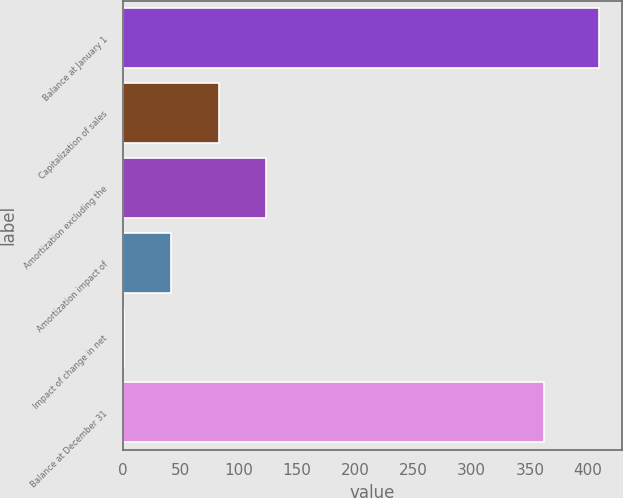Convert chart. <chart><loc_0><loc_0><loc_500><loc_500><bar_chart><fcel>Balance at January 1<fcel>Capitalization of sales<fcel>Amortization excluding the<fcel>Amortization impact of<fcel>Impact of change in net<fcel>Balance at December 31<nl><fcel>409<fcel>82.6<fcel>123.4<fcel>41.8<fcel>1<fcel>362<nl></chart> 